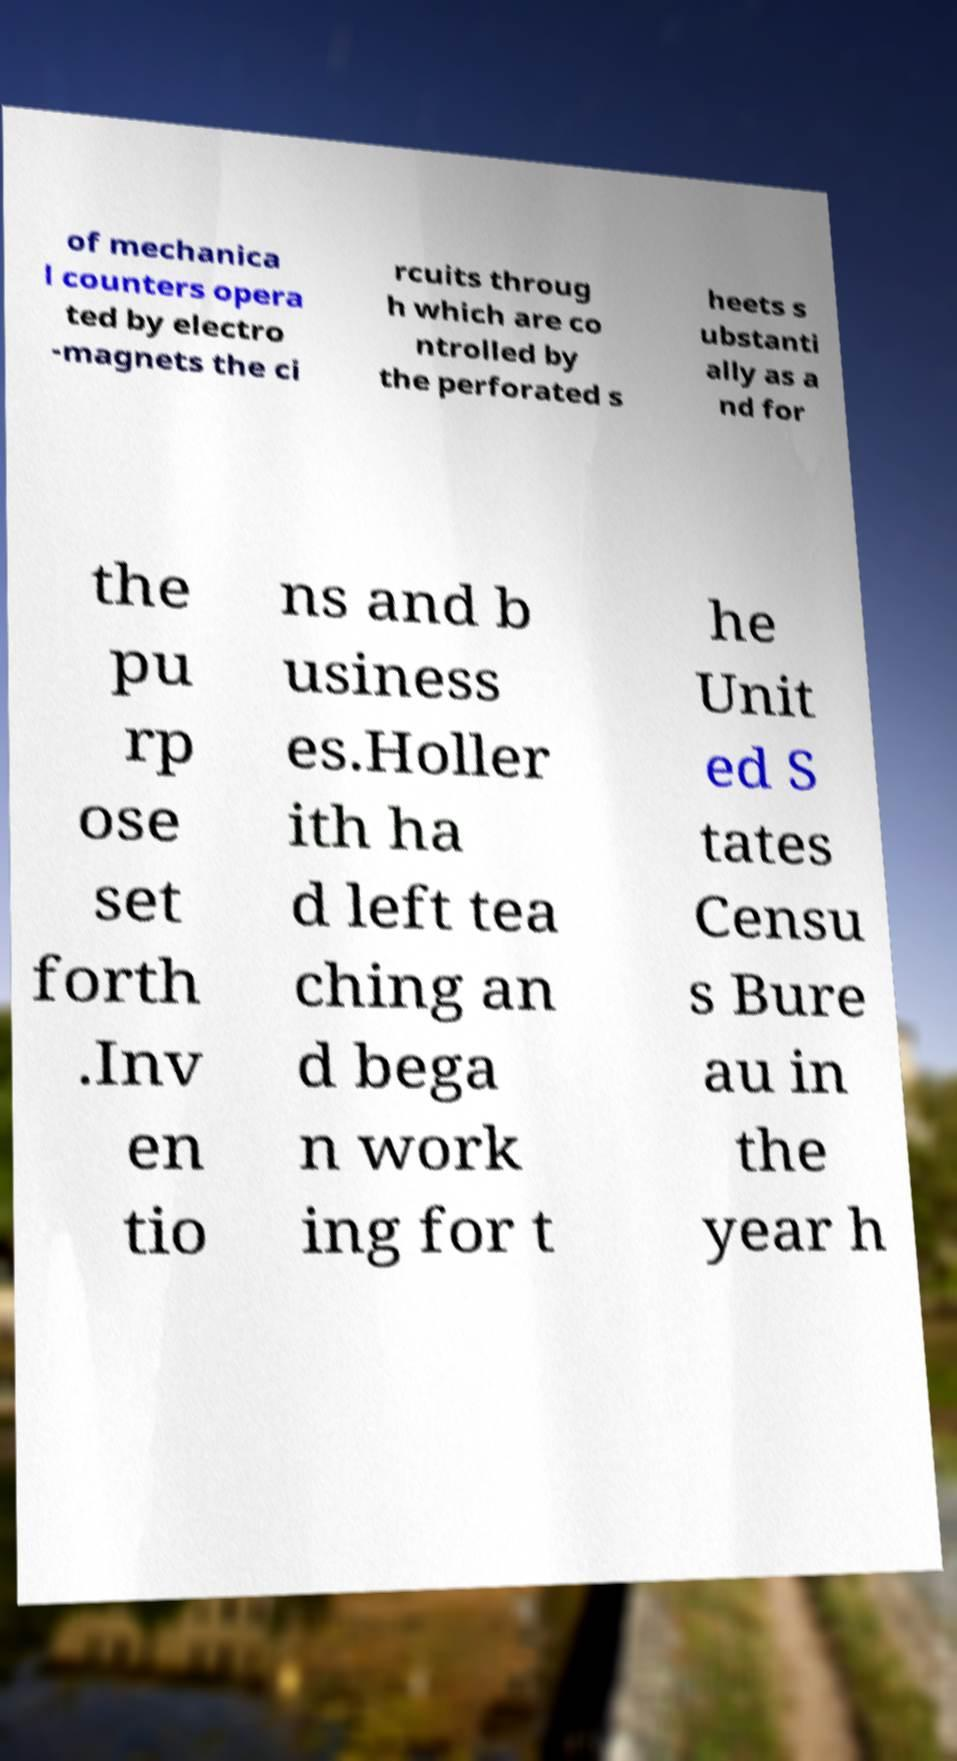Please identify and transcribe the text found in this image. of mechanica l counters opera ted by electro -magnets the ci rcuits throug h which are co ntrolled by the perforated s heets s ubstanti ally as a nd for the pu rp ose set forth .Inv en tio ns and b usiness es.Holler ith ha d left tea ching an d bega n work ing for t he Unit ed S tates Censu s Bure au in the year h 